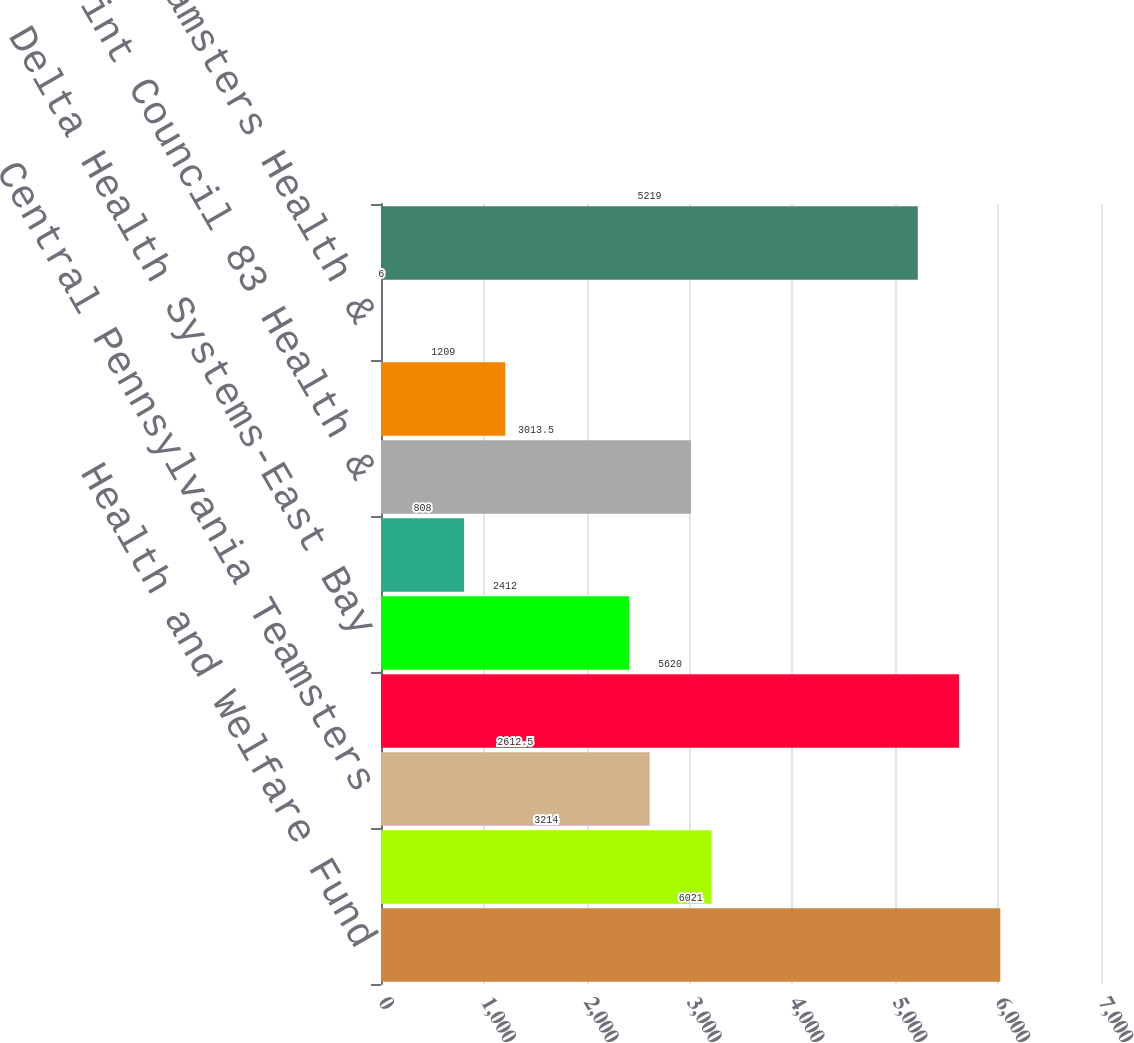<chart> <loc_0><loc_0><loc_500><loc_500><bar_chart><fcel>Health and Welfare Fund<fcel>Bay Area Delivery Drivers<fcel>Central Pennsylvania Teamsters<fcel>Central States South East &<fcel>Delta Health Systems-East Bay<fcel>Employer-Teamster Local Nos<fcel>Joint Council 83 Health &<fcel>Local 191 Teamsters Health<fcel>Local 401 Teamsters Health &<fcel>Local 804 Welfare Trust Fund<nl><fcel>6021<fcel>3214<fcel>2612.5<fcel>5620<fcel>2412<fcel>808<fcel>3013.5<fcel>1209<fcel>6<fcel>5219<nl></chart> 